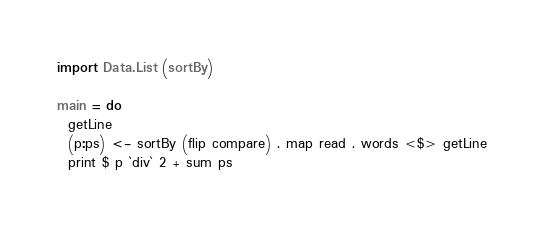<code> <loc_0><loc_0><loc_500><loc_500><_Haskell_>import Data.List (sortBy)

main = do
  getLine
  (p:ps) <- sortBy (flip compare) . map read . words <$> getLine
  print $ p `div` 2 + sum ps</code> 